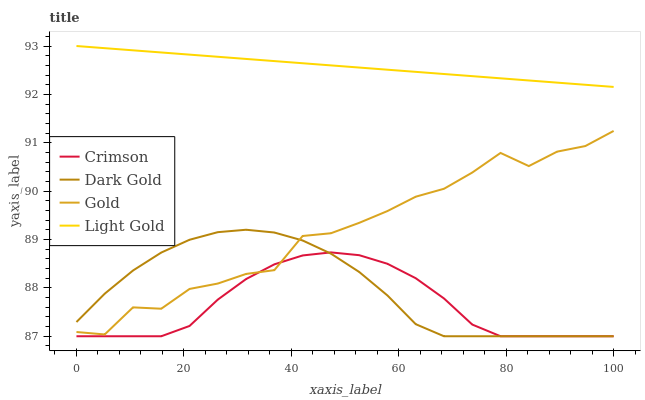Does Crimson have the minimum area under the curve?
Answer yes or no. Yes. Does Light Gold have the maximum area under the curve?
Answer yes or no. Yes. Does Gold have the minimum area under the curve?
Answer yes or no. No. Does Gold have the maximum area under the curve?
Answer yes or no. No. Is Light Gold the smoothest?
Answer yes or no. Yes. Is Gold the roughest?
Answer yes or no. Yes. Is Gold the smoothest?
Answer yes or no. No. Is Light Gold the roughest?
Answer yes or no. No. Does Crimson have the lowest value?
Answer yes or no. Yes. Does Gold have the lowest value?
Answer yes or no. No. Does Light Gold have the highest value?
Answer yes or no. Yes. Does Gold have the highest value?
Answer yes or no. No. Is Gold less than Light Gold?
Answer yes or no. Yes. Is Light Gold greater than Gold?
Answer yes or no. Yes. Does Crimson intersect Dark Gold?
Answer yes or no. Yes. Is Crimson less than Dark Gold?
Answer yes or no. No. Is Crimson greater than Dark Gold?
Answer yes or no. No. Does Gold intersect Light Gold?
Answer yes or no. No. 